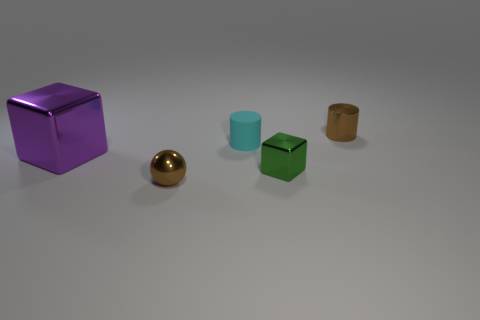Add 5 small brown metal balls. How many objects exist? 10 Subtract 2 cubes. How many cubes are left? 0 Subtract all big purple metallic balls. Subtract all small cyan objects. How many objects are left? 4 Add 3 large purple cubes. How many large purple cubes are left? 4 Add 3 tiny red spheres. How many tiny red spheres exist? 3 Subtract 1 green cubes. How many objects are left? 4 Subtract all cylinders. How many objects are left? 3 Subtract all cyan blocks. Subtract all yellow balls. How many blocks are left? 2 Subtract all gray cylinders. How many gray spheres are left? 0 